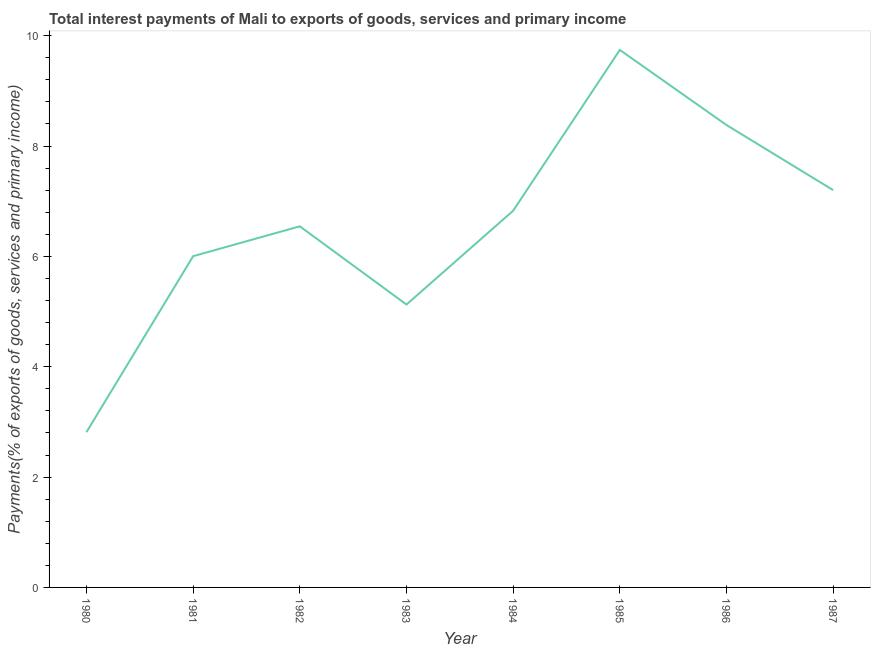What is the total interest payments on external debt in 1980?
Make the answer very short. 2.81. Across all years, what is the maximum total interest payments on external debt?
Your response must be concise. 9.74. Across all years, what is the minimum total interest payments on external debt?
Provide a succinct answer. 2.81. In which year was the total interest payments on external debt minimum?
Ensure brevity in your answer.  1980. What is the sum of the total interest payments on external debt?
Provide a short and direct response. 52.64. What is the difference between the total interest payments on external debt in 1982 and 1987?
Give a very brief answer. -0.66. What is the average total interest payments on external debt per year?
Your response must be concise. 6.58. What is the median total interest payments on external debt?
Offer a terse response. 6.69. In how many years, is the total interest payments on external debt greater than 4.4 %?
Your answer should be very brief. 7. What is the ratio of the total interest payments on external debt in 1981 to that in 1987?
Make the answer very short. 0.83. Is the difference between the total interest payments on external debt in 1985 and 1987 greater than the difference between any two years?
Make the answer very short. No. What is the difference between the highest and the second highest total interest payments on external debt?
Offer a very short reply. 1.36. What is the difference between the highest and the lowest total interest payments on external debt?
Ensure brevity in your answer.  6.93. In how many years, is the total interest payments on external debt greater than the average total interest payments on external debt taken over all years?
Your answer should be compact. 4. Does the graph contain grids?
Keep it short and to the point. No. What is the title of the graph?
Provide a short and direct response. Total interest payments of Mali to exports of goods, services and primary income. What is the label or title of the Y-axis?
Offer a very short reply. Payments(% of exports of goods, services and primary income). What is the Payments(% of exports of goods, services and primary income) of 1980?
Provide a short and direct response. 2.81. What is the Payments(% of exports of goods, services and primary income) in 1981?
Keep it short and to the point. 6. What is the Payments(% of exports of goods, services and primary income) in 1982?
Your response must be concise. 6.54. What is the Payments(% of exports of goods, services and primary income) of 1983?
Provide a succinct answer. 5.13. What is the Payments(% of exports of goods, services and primary income) of 1984?
Offer a very short reply. 6.83. What is the Payments(% of exports of goods, services and primary income) in 1985?
Give a very brief answer. 9.74. What is the Payments(% of exports of goods, services and primary income) of 1986?
Your answer should be very brief. 8.38. What is the Payments(% of exports of goods, services and primary income) of 1987?
Your answer should be compact. 7.2. What is the difference between the Payments(% of exports of goods, services and primary income) in 1980 and 1981?
Ensure brevity in your answer.  -3.19. What is the difference between the Payments(% of exports of goods, services and primary income) in 1980 and 1982?
Make the answer very short. -3.73. What is the difference between the Payments(% of exports of goods, services and primary income) in 1980 and 1983?
Your response must be concise. -2.31. What is the difference between the Payments(% of exports of goods, services and primary income) in 1980 and 1984?
Your response must be concise. -4.01. What is the difference between the Payments(% of exports of goods, services and primary income) in 1980 and 1985?
Your answer should be very brief. -6.93. What is the difference between the Payments(% of exports of goods, services and primary income) in 1980 and 1986?
Give a very brief answer. -5.57. What is the difference between the Payments(% of exports of goods, services and primary income) in 1980 and 1987?
Offer a very short reply. -4.39. What is the difference between the Payments(% of exports of goods, services and primary income) in 1981 and 1982?
Make the answer very short. -0.54. What is the difference between the Payments(% of exports of goods, services and primary income) in 1981 and 1983?
Keep it short and to the point. 0.88. What is the difference between the Payments(% of exports of goods, services and primary income) in 1981 and 1984?
Provide a succinct answer. -0.82. What is the difference between the Payments(% of exports of goods, services and primary income) in 1981 and 1985?
Keep it short and to the point. -3.74. What is the difference between the Payments(% of exports of goods, services and primary income) in 1981 and 1986?
Keep it short and to the point. -2.38. What is the difference between the Payments(% of exports of goods, services and primary income) in 1981 and 1987?
Provide a short and direct response. -1.2. What is the difference between the Payments(% of exports of goods, services and primary income) in 1982 and 1983?
Make the answer very short. 1.42. What is the difference between the Payments(% of exports of goods, services and primary income) in 1982 and 1984?
Offer a terse response. -0.28. What is the difference between the Payments(% of exports of goods, services and primary income) in 1982 and 1985?
Your answer should be very brief. -3.2. What is the difference between the Payments(% of exports of goods, services and primary income) in 1982 and 1986?
Make the answer very short. -1.84. What is the difference between the Payments(% of exports of goods, services and primary income) in 1982 and 1987?
Make the answer very short. -0.66. What is the difference between the Payments(% of exports of goods, services and primary income) in 1983 and 1984?
Give a very brief answer. -1.7. What is the difference between the Payments(% of exports of goods, services and primary income) in 1983 and 1985?
Your answer should be very brief. -4.61. What is the difference between the Payments(% of exports of goods, services and primary income) in 1983 and 1986?
Give a very brief answer. -3.25. What is the difference between the Payments(% of exports of goods, services and primary income) in 1983 and 1987?
Make the answer very short. -2.07. What is the difference between the Payments(% of exports of goods, services and primary income) in 1984 and 1985?
Offer a terse response. -2.91. What is the difference between the Payments(% of exports of goods, services and primary income) in 1984 and 1986?
Give a very brief answer. -1.55. What is the difference between the Payments(% of exports of goods, services and primary income) in 1984 and 1987?
Offer a terse response. -0.37. What is the difference between the Payments(% of exports of goods, services and primary income) in 1985 and 1986?
Your answer should be compact. 1.36. What is the difference between the Payments(% of exports of goods, services and primary income) in 1985 and 1987?
Keep it short and to the point. 2.54. What is the difference between the Payments(% of exports of goods, services and primary income) in 1986 and 1987?
Keep it short and to the point. 1.18. What is the ratio of the Payments(% of exports of goods, services and primary income) in 1980 to that in 1981?
Give a very brief answer. 0.47. What is the ratio of the Payments(% of exports of goods, services and primary income) in 1980 to that in 1982?
Make the answer very short. 0.43. What is the ratio of the Payments(% of exports of goods, services and primary income) in 1980 to that in 1983?
Give a very brief answer. 0.55. What is the ratio of the Payments(% of exports of goods, services and primary income) in 1980 to that in 1984?
Provide a short and direct response. 0.41. What is the ratio of the Payments(% of exports of goods, services and primary income) in 1980 to that in 1985?
Your answer should be compact. 0.29. What is the ratio of the Payments(% of exports of goods, services and primary income) in 1980 to that in 1986?
Your response must be concise. 0.34. What is the ratio of the Payments(% of exports of goods, services and primary income) in 1980 to that in 1987?
Provide a succinct answer. 0.39. What is the ratio of the Payments(% of exports of goods, services and primary income) in 1981 to that in 1982?
Offer a very short reply. 0.92. What is the ratio of the Payments(% of exports of goods, services and primary income) in 1981 to that in 1983?
Offer a terse response. 1.17. What is the ratio of the Payments(% of exports of goods, services and primary income) in 1981 to that in 1984?
Your answer should be compact. 0.88. What is the ratio of the Payments(% of exports of goods, services and primary income) in 1981 to that in 1985?
Your answer should be very brief. 0.62. What is the ratio of the Payments(% of exports of goods, services and primary income) in 1981 to that in 1986?
Provide a short and direct response. 0.72. What is the ratio of the Payments(% of exports of goods, services and primary income) in 1981 to that in 1987?
Provide a short and direct response. 0.83. What is the ratio of the Payments(% of exports of goods, services and primary income) in 1982 to that in 1983?
Offer a terse response. 1.28. What is the ratio of the Payments(% of exports of goods, services and primary income) in 1982 to that in 1985?
Your answer should be compact. 0.67. What is the ratio of the Payments(% of exports of goods, services and primary income) in 1982 to that in 1986?
Offer a terse response. 0.78. What is the ratio of the Payments(% of exports of goods, services and primary income) in 1982 to that in 1987?
Provide a succinct answer. 0.91. What is the ratio of the Payments(% of exports of goods, services and primary income) in 1983 to that in 1984?
Keep it short and to the point. 0.75. What is the ratio of the Payments(% of exports of goods, services and primary income) in 1983 to that in 1985?
Make the answer very short. 0.53. What is the ratio of the Payments(% of exports of goods, services and primary income) in 1983 to that in 1986?
Offer a very short reply. 0.61. What is the ratio of the Payments(% of exports of goods, services and primary income) in 1983 to that in 1987?
Give a very brief answer. 0.71. What is the ratio of the Payments(% of exports of goods, services and primary income) in 1984 to that in 1985?
Provide a short and direct response. 0.7. What is the ratio of the Payments(% of exports of goods, services and primary income) in 1984 to that in 1986?
Your response must be concise. 0.81. What is the ratio of the Payments(% of exports of goods, services and primary income) in 1984 to that in 1987?
Offer a terse response. 0.95. What is the ratio of the Payments(% of exports of goods, services and primary income) in 1985 to that in 1986?
Offer a terse response. 1.16. What is the ratio of the Payments(% of exports of goods, services and primary income) in 1985 to that in 1987?
Ensure brevity in your answer.  1.35. What is the ratio of the Payments(% of exports of goods, services and primary income) in 1986 to that in 1987?
Give a very brief answer. 1.16. 